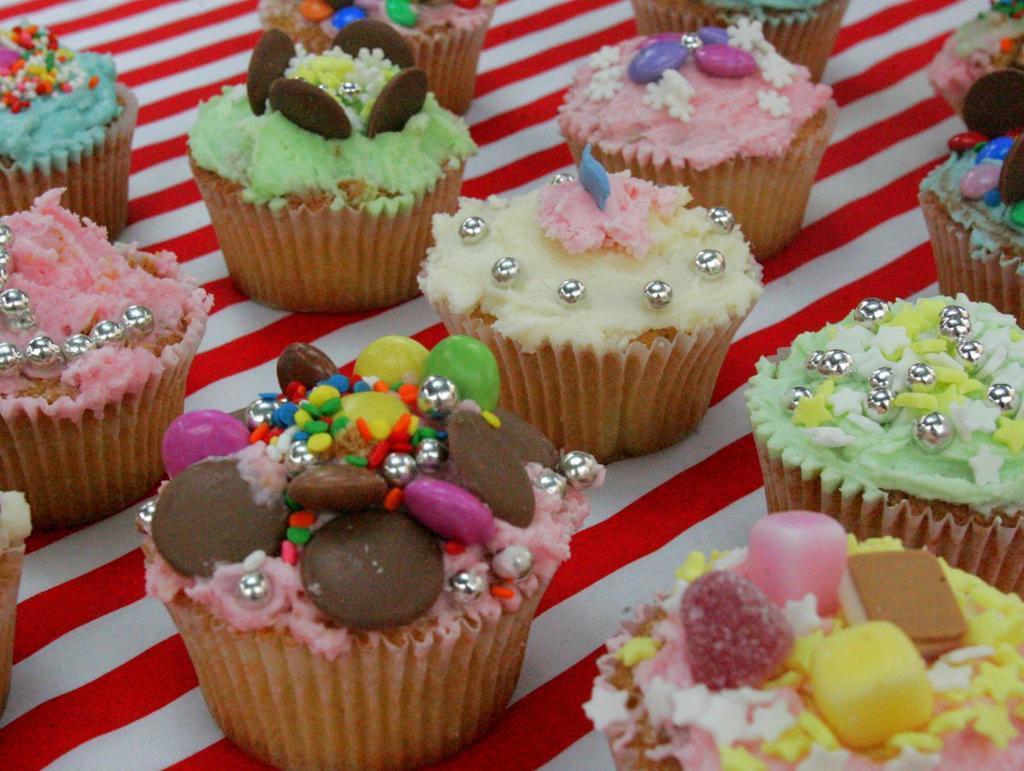Could you give a brief overview of what you see in this image? In this image, there are cupcakes placed on the table. 